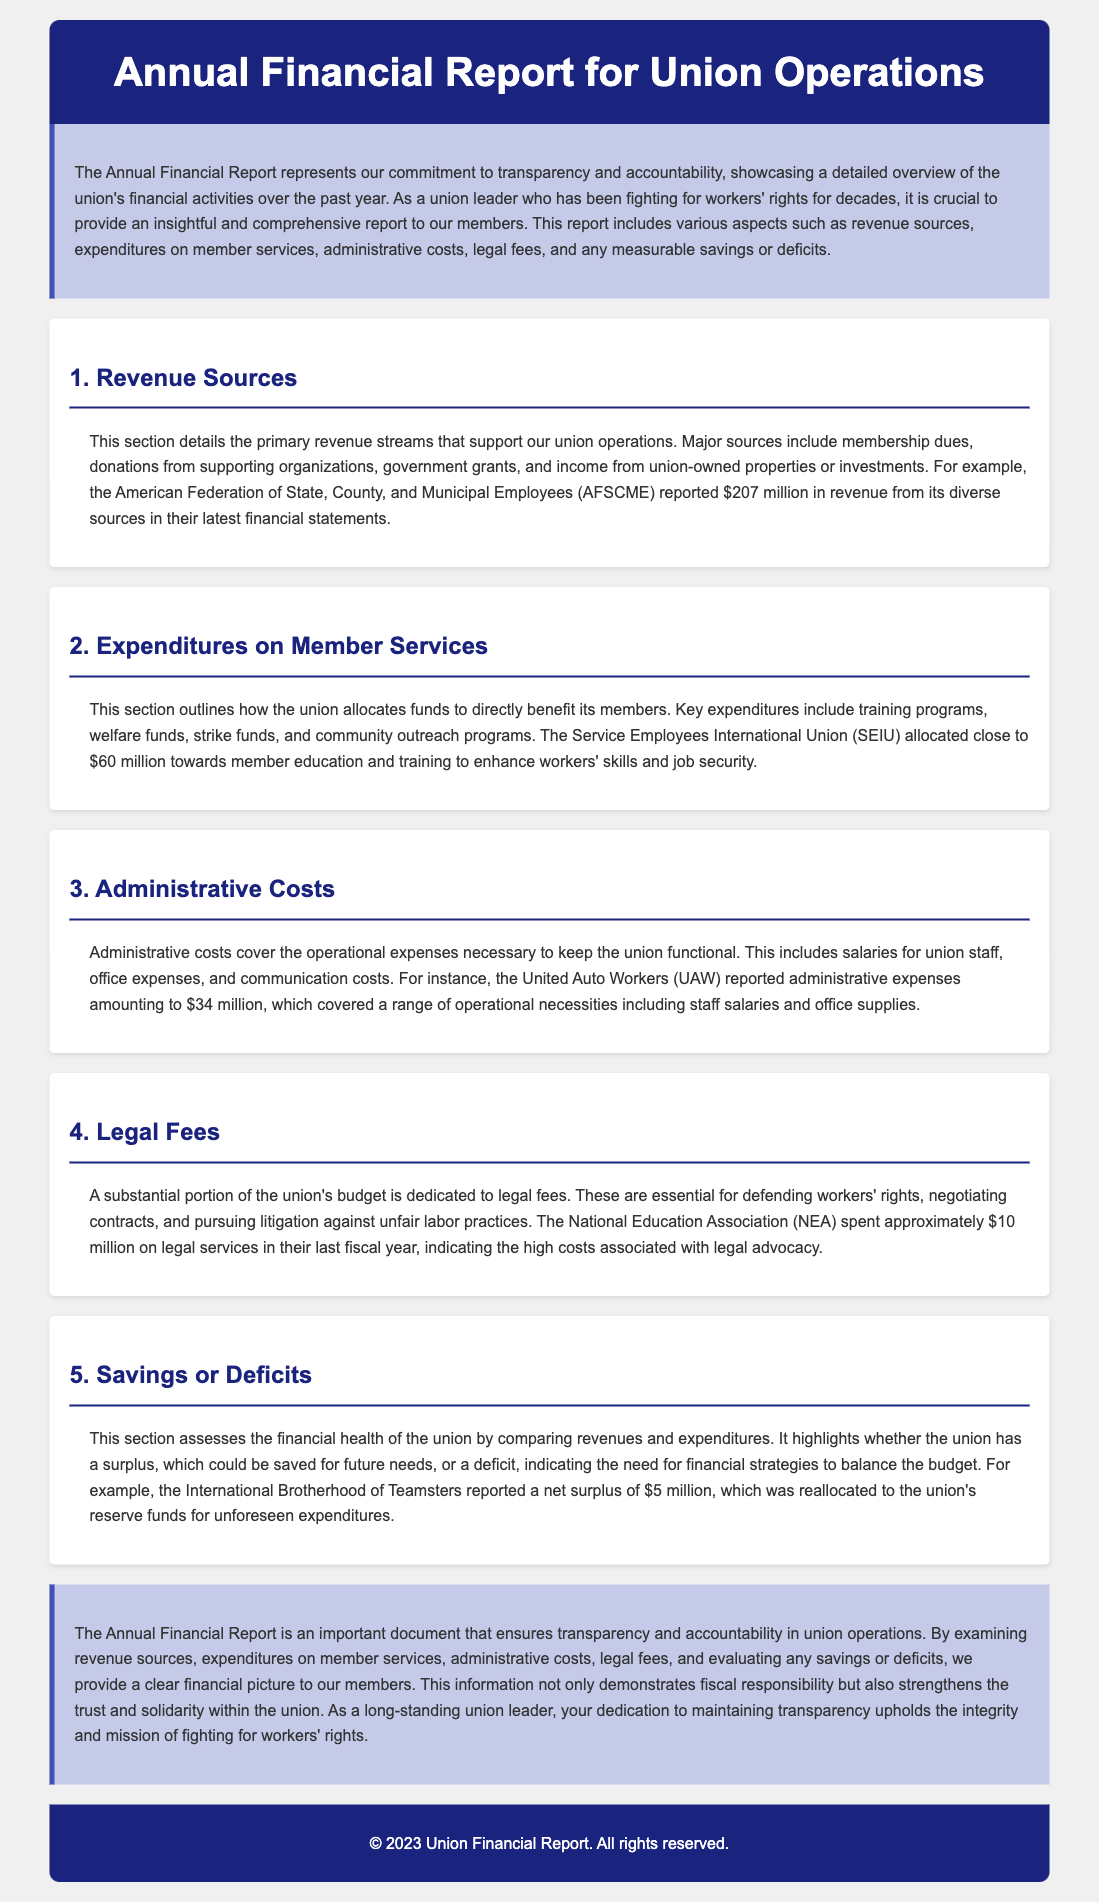What are the major revenue sources? The document lists major revenue sources such as membership dues, donations from supporting organizations, government grants, and income from union-owned properties or investments.
Answer: Membership dues, donations, government grants, income from properties How much did the SEIU allocate for member education and training? The document states that the SEIU allocated close to $60 million towards member education and training.
Answer: $60 million What is included in administrative costs? Administrative costs encompass salaries for union staff, office expenses, and communication costs as mentioned in the document.
Answer: Salaries, office expenses, communication costs How much did the NEA spend on legal services? The document indicates that the National Education Association spent approximately $10 million on legal services in their last fiscal year.
Answer: $10 million What was the net surplus reported by the International Brotherhood of Teamsters? According to the document, the International Brotherhood of Teamsters reported a net surplus of $5 million.
Answer: $5 million What does the report emphasize about its purpose? The report emphasizes its commitment to transparency and accountability in showcasing the union's financial activities.
Answer: Transparency and accountability What type of expenditures are highlighted in the expenditures section? The expenditures section highlights expenditures such as training programs, welfare funds, and strike funds.
Answer: Training programs, welfare funds, strike funds What year does the financial report cover? The financial report represents an overview of the union's activities over the past year, which is stated to be 2023.
Answer: 2023 